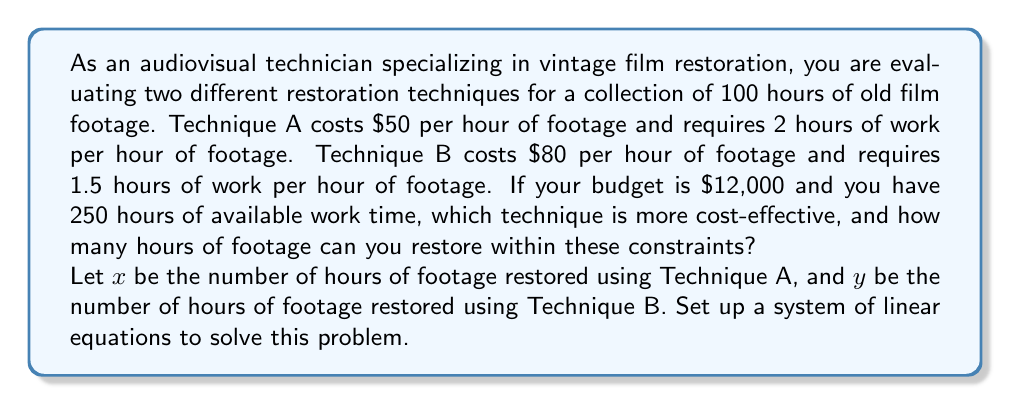Can you solve this math problem? To solve this problem, we need to set up a system of linear equations based on the given constraints and then determine which technique is more cost-effective.

1. Budget constraint:
   The total cost should not exceed $12,000
   $$50x + 80y \leq 12000$$

2. Time constraint:
   The total work time should not exceed 250 hours
   $$2x + 1.5y \leq 250$$

3. Total footage constraint:
   The sum of footage restored by both techniques should equal 100 hours
   $$x + y = 100$$

Now, let's solve this system of equations:

From equation 3, we can express y in terms of x:
$$y = 100 - x$$

Substituting this into equations 1 and 2:

1. $$50x + 80(100 - x) \leq 12000$$
   $$50x + 8000 - 80x \leq 12000$$
   $$-30x \leq 4000$$
   $$x \geq -133.33$$ (This is always true for positive x)

2. $$2x + 1.5(100 - x) \leq 250$$
   $$2x + 150 - 1.5x \leq 250$$
   $$0.5x \leq 100$$
   $$x \leq 200$$

Since x represents hours of footage, it must be non-negative and not exceed 100. Therefore, any value of x between 0 and 100 satisfies these constraints.

To determine which technique is more cost-effective, we need to compare the cost per hour of footage:

Technique A: $50 per hour of footage
Technique B: $80 per hour of footage

Technique A is more cost-effective as it has a lower cost per hour of footage.

To maximize the amount of footage restored within the constraints, we should use Technique A for as much footage as possible. The limiting factor is the time constraint:

$$2x \leq 250$$
$$x \leq 125$$

However, we only have 100 hours of footage to restore. Therefore, we can restore all 100 hours using Technique A.
Answer: Technique A is more cost-effective at $50 per hour of footage compared to $80 for Technique B. Using Technique A, you can restore all 100 hours of footage within the given budget and time constraints. 